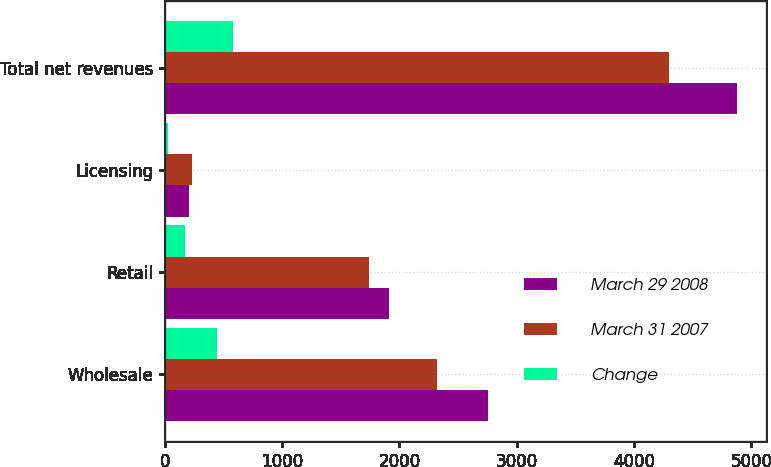<chart> <loc_0><loc_0><loc_500><loc_500><stacked_bar_chart><ecel><fcel>Wholesale<fcel>Retail<fcel>Licensing<fcel>Total net revenues<nl><fcel>March 29 2008<fcel>2758.1<fcel>1912.6<fcel>209.4<fcel>4880.1<nl><fcel>March 31 2007<fcel>2315.9<fcel>1743.2<fcel>236.3<fcel>4295.4<nl><fcel>Change<fcel>442.2<fcel>169.4<fcel>26.9<fcel>584.7<nl></chart> 